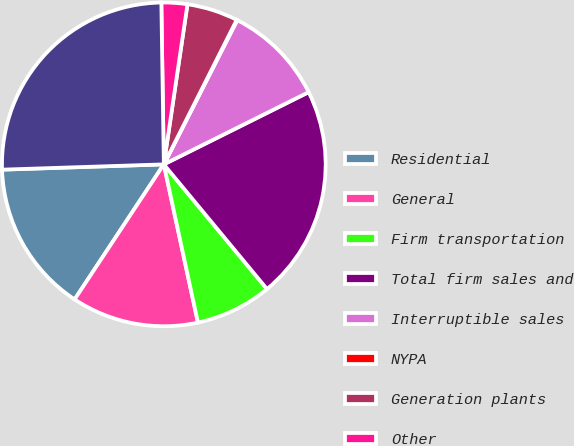<chart> <loc_0><loc_0><loc_500><loc_500><pie_chart><fcel>Residential<fcel>General<fcel>Firm transportation<fcel>Total firm sales and<fcel>Interruptible sales<fcel>NYPA<fcel>Generation plants<fcel>Other<fcel>Total<nl><fcel>15.19%<fcel>12.67%<fcel>7.62%<fcel>21.36%<fcel>10.14%<fcel>0.06%<fcel>5.1%<fcel>2.58%<fcel>25.27%<nl></chart> 